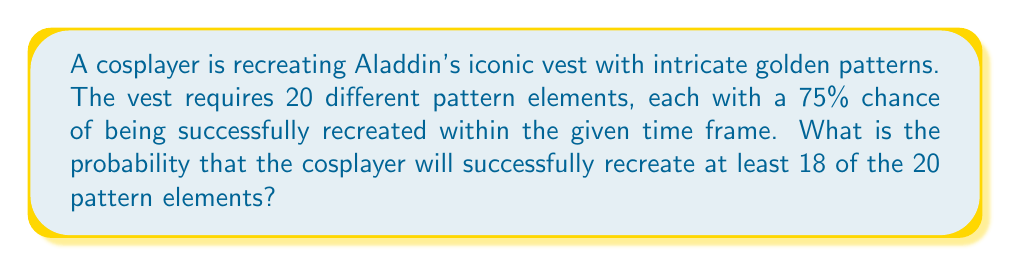Could you help me with this problem? Let's approach this step-by-step:

1) This scenario follows a binomial distribution, where:
   $n = 20$ (total number of pattern elements)
   $p = 0.75$ (probability of success for each element)
   $q = 1 - p = 0.25$ (probability of failure for each element)

2) We need to find the probability of recreating 18, 19, or 20 elements successfully.

3) The probability mass function for a binomial distribution is:

   $P(X = k) = \binom{n}{k} p^k q^{n-k}$

4) We need to calculate:

   $P(X \geq 18) = P(X = 18) + P(X = 19) + P(X = 20)$

5) Let's calculate each term:

   $P(X = 18) = \binom{20}{18} (0.75)^{18} (0.25)^2 = 190 \cdot 0.75^{18} \cdot 0.25^2 = 0.2252$

   $P(X = 19) = \binom{20}{19} (0.75)^{19} (0.25)^1 = 20 \cdot 0.75^{19} \cdot 0.25 = 0.1001$

   $P(X = 20) = \binom{20}{20} (0.75)^{20} (0.25)^0 = 1 \cdot 0.75^{20} = 0.0317$

6) Sum these probabilities:

   $P(X \geq 18) = 0.2252 + 0.1001 + 0.0317 = 0.3570$

Therefore, the probability of successfully recreating at least 18 out of 20 pattern elements is approximately 0.3570 or 35.70%.
Answer: 0.3570 